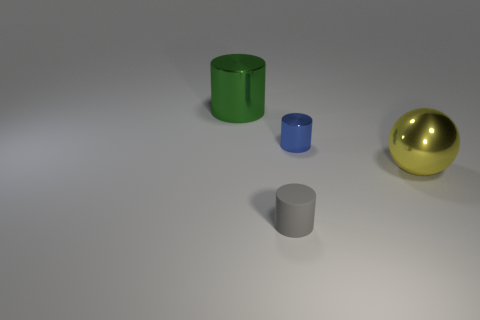Add 1 metal cylinders. How many objects exist? 5 Subtract all cylinders. How many objects are left? 1 Add 2 tiny red shiny cylinders. How many tiny red shiny cylinders exist? 2 Subtract 0 red cylinders. How many objects are left? 4 Subtract all small green matte blocks. Subtract all large yellow balls. How many objects are left? 3 Add 4 large green things. How many large green things are left? 5 